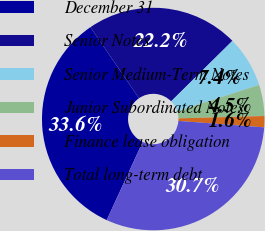Convert chart. <chart><loc_0><loc_0><loc_500><loc_500><pie_chart><fcel>December 31<fcel>Senior Notes<fcel>Senior Medium-Term Notes<fcel>Junior Subordinated Notes<fcel>Finance lease obligation<fcel>Total long-term debt<nl><fcel>33.58%<fcel>22.15%<fcel>7.44%<fcel>4.53%<fcel>1.62%<fcel>30.67%<nl></chart> 